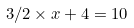<formula> <loc_0><loc_0><loc_500><loc_500>3 / 2 \times x + 4 = 1 0</formula> 